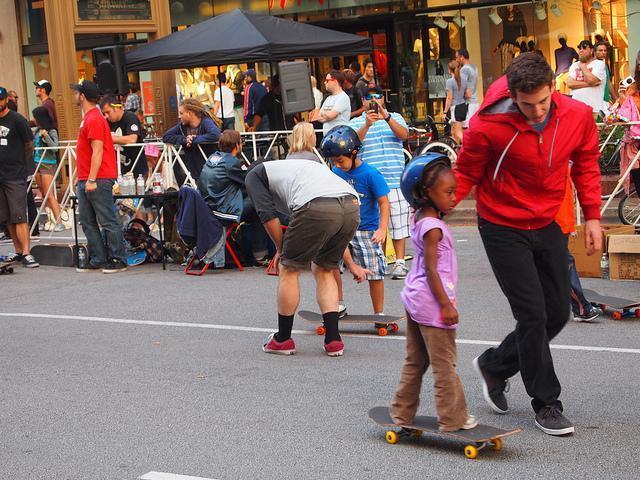How many men are wearing scarves?
Give a very brief answer. 0. How many stop lights are visible?
Give a very brief answer. 0. How many people can you see?
Give a very brief answer. 9. 